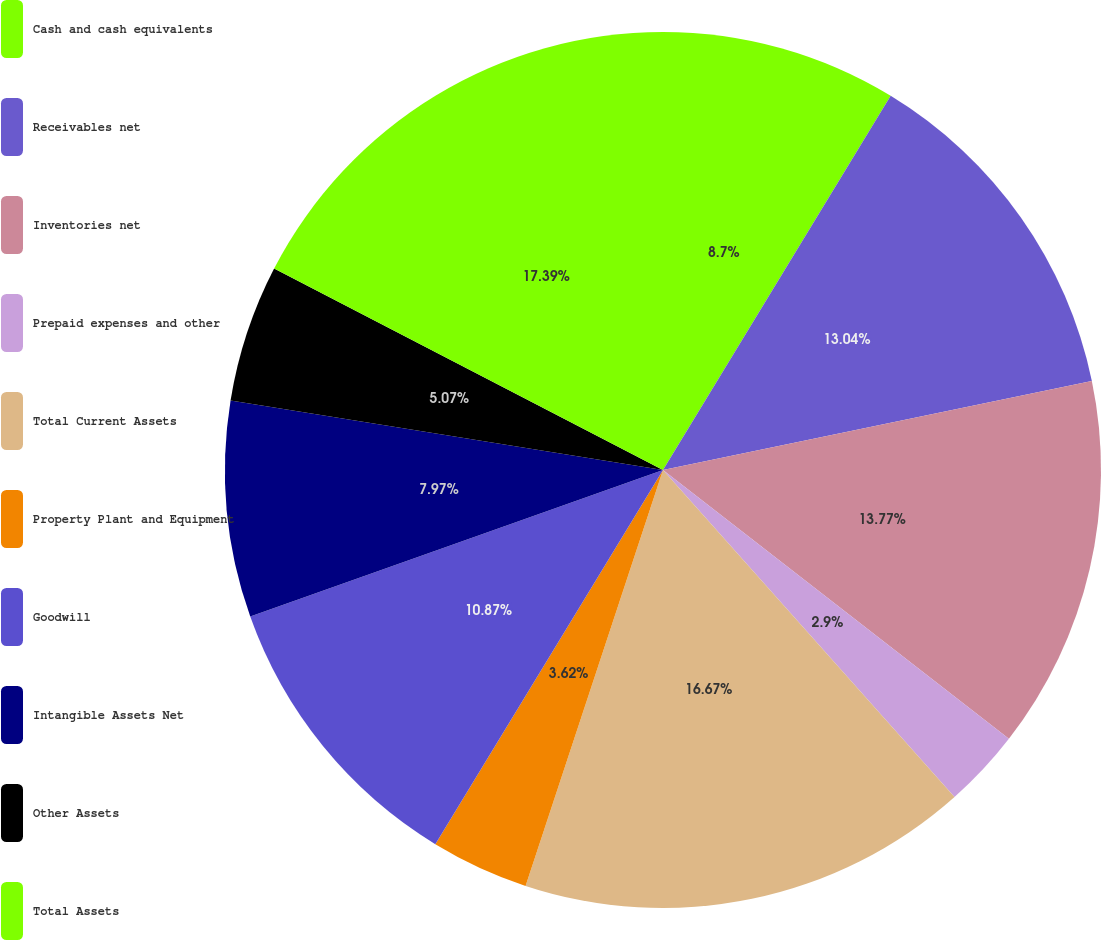Convert chart. <chart><loc_0><loc_0><loc_500><loc_500><pie_chart><fcel>Cash and cash equivalents<fcel>Receivables net<fcel>Inventories net<fcel>Prepaid expenses and other<fcel>Total Current Assets<fcel>Property Plant and Equipment<fcel>Goodwill<fcel>Intangible Assets Net<fcel>Other Assets<fcel>Total Assets<nl><fcel>8.7%<fcel>13.04%<fcel>13.77%<fcel>2.9%<fcel>16.67%<fcel>3.62%<fcel>10.87%<fcel>7.97%<fcel>5.07%<fcel>17.39%<nl></chart> 